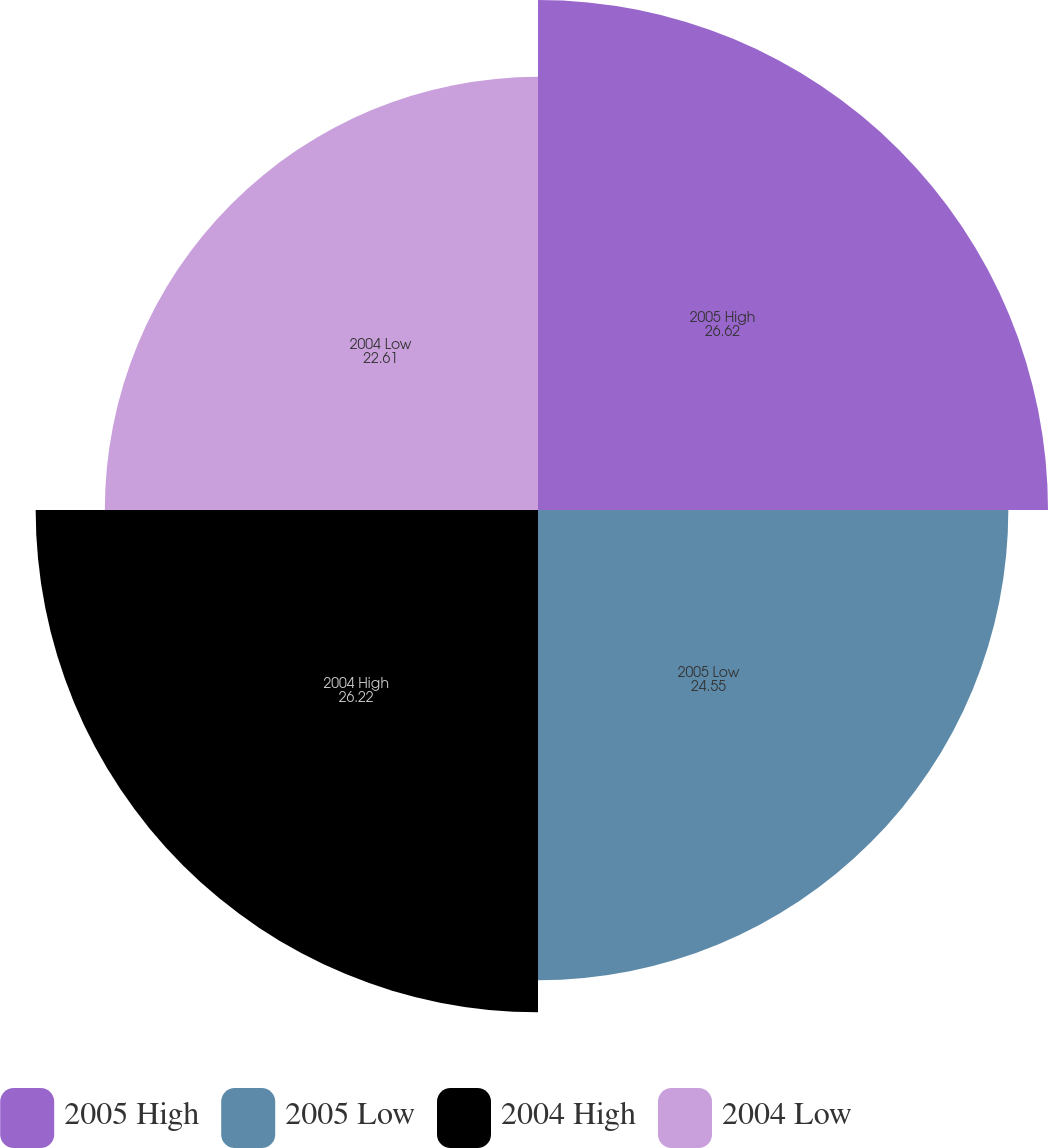Convert chart. <chart><loc_0><loc_0><loc_500><loc_500><pie_chart><fcel>2005 High<fcel>2005 Low<fcel>2004 High<fcel>2004 Low<nl><fcel>26.62%<fcel>24.55%<fcel>26.22%<fcel>22.61%<nl></chart> 